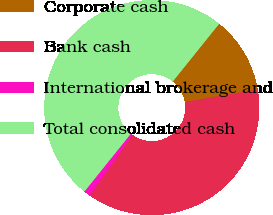Convert chart. <chart><loc_0><loc_0><loc_500><loc_500><pie_chart><fcel>Corporate cash<fcel>Bank cash<fcel>International brokerage and<fcel>Total consolidated cash<nl><fcel>11.53%<fcel>37.48%<fcel>0.98%<fcel>50.0%<nl></chart> 